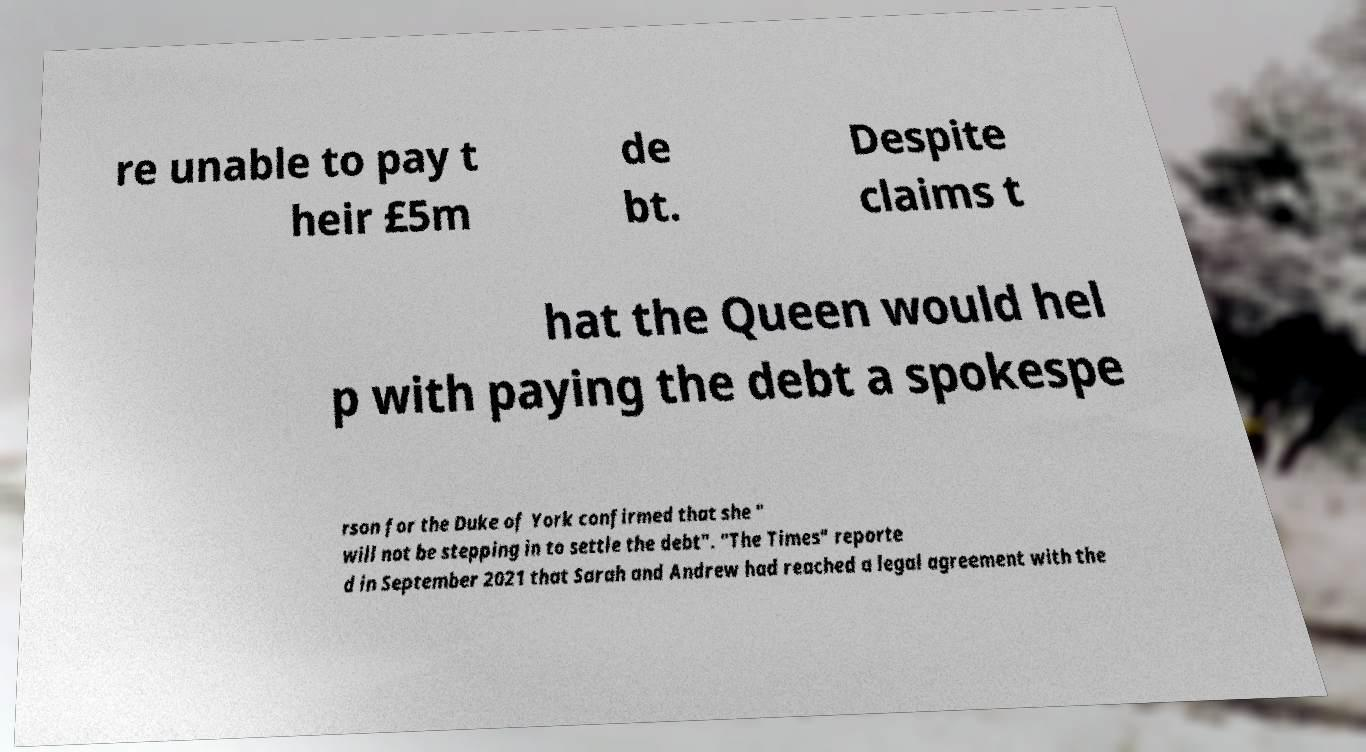I need the written content from this picture converted into text. Can you do that? re unable to pay t heir £5m de bt. Despite claims t hat the Queen would hel p with paying the debt a spokespe rson for the Duke of York confirmed that she " will not be stepping in to settle the debt". "The Times" reporte d in September 2021 that Sarah and Andrew had reached a legal agreement with the 